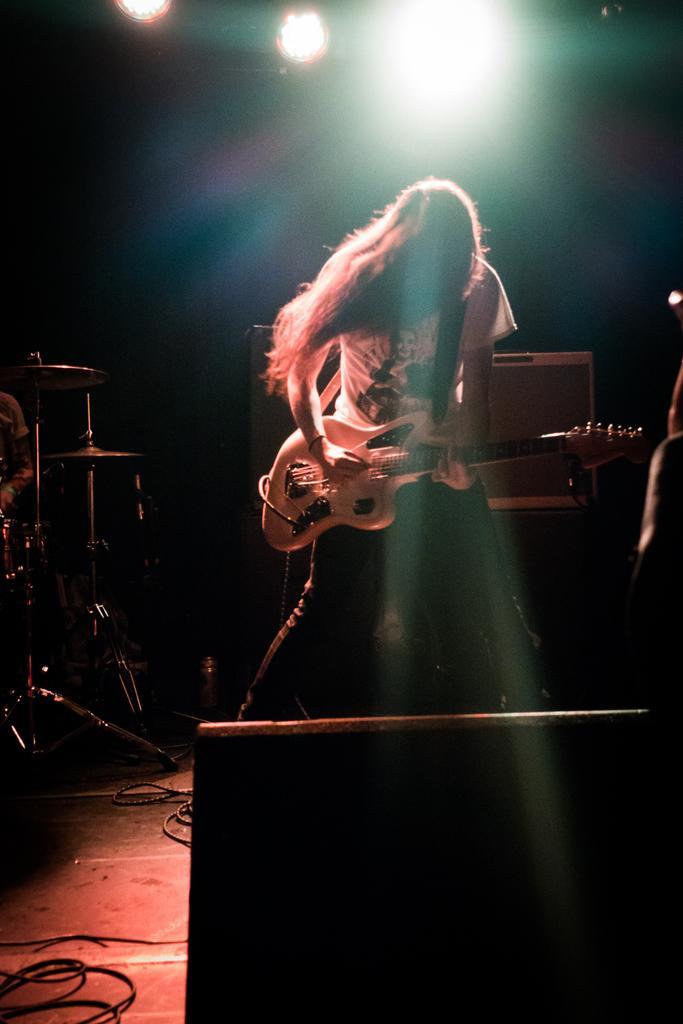In one or two sentences, can you explain what this image depicts? In this picture I can see a person playing the guitar in the middle. At the top there are lights, on the left side there are musical instruments. 